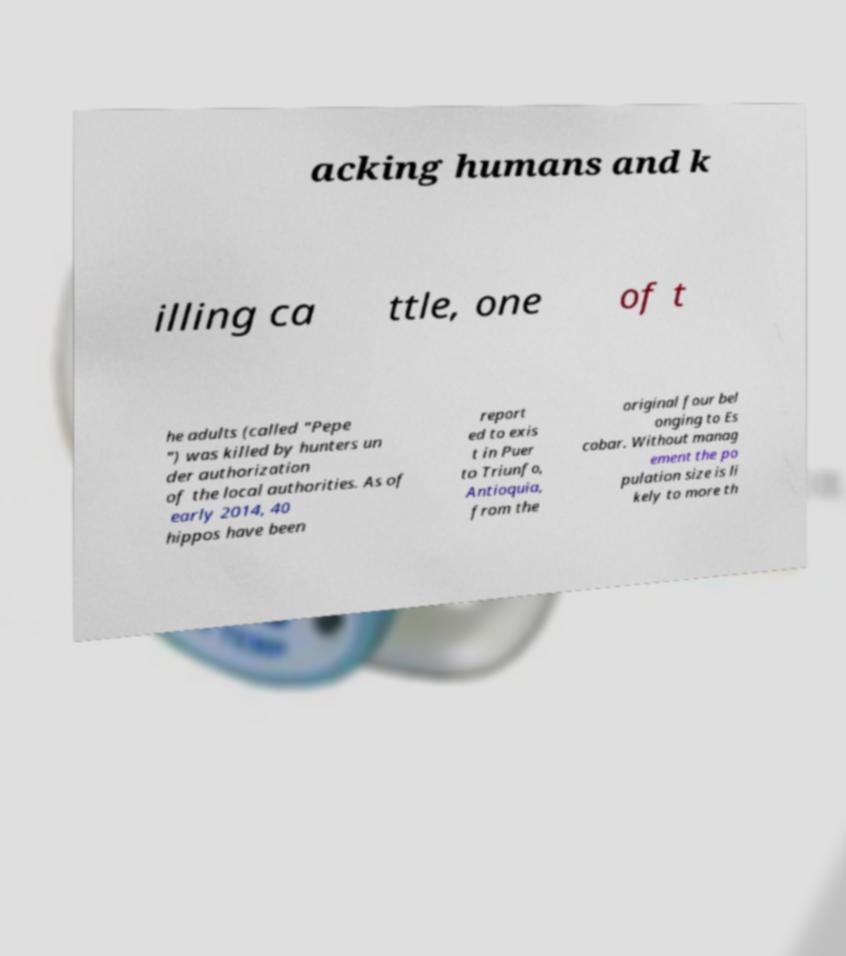For documentation purposes, I need the text within this image transcribed. Could you provide that? acking humans and k illing ca ttle, one of t he adults (called "Pepe ") was killed by hunters un der authorization of the local authorities. As of early 2014, 40 hippos have been report ed to exis t in Puer to Triunfo, Antioquia, from the original four bel onging to Es cobar. Without manag ement the po pulation size is li kely to more th 